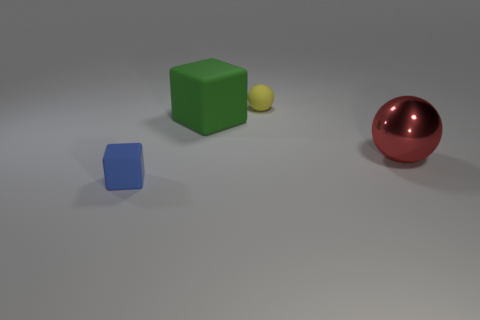Is there any other thing that is made of the same material as the big red ball?
Provide a succinct answer. No. Does the ball that is to the left of the red metallic sphere have the same material as the large green block that is left of the big red metal object?
Give a very brief answer. Yes. What number of cyan rubber things are the same shape as the blue thing?
Offer a terse response. 0. What number of big rubber cubes are the same color as the tiny rubber sphere?
Make the answer very short. 0. Do the rubber thing to the right of the green block and the thing in front of the red shiny thing have the same shape?
Provide a succinct answer. No. There is a tiny matte thing on the left side of the yellow thing behind the large red thing; what number of rubber balls are behind it?
Provide a short and direct response. 1. There is a small thing in front of the small matte thing that is behind the small blue block left of the large red thing; what is its material?
Provide a short and direct response. Rubber. Does the ball that is to the left of the big red metal thing have the same material as the blue cube?
Provide a short and direct response. Yes. What number of matte things have the same size as the metal thing?
Your answer should be compact. 1. Are there more balls left of the big rubber block than blue matte objects in front of the blue rubber cube?
Make the answer very short. No. 